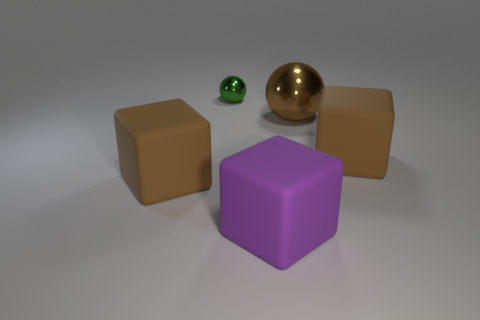Do the tiny object and the matte object to the right of the brown metallic ball have the same color?
Your answer should be very brief. No. Are there any brown spheres that have the same size as the brown shiny thing?
Offer a terse response. No. There is a brown block that is right of the green shiny sphere; what is it made of?
Ensure brevity in your answer.  Rubber. Is the number of large metallic objects left of the tiny metal sphere the same as the number of big cubes that are on the right side of the big brown sphere?
Your response must be concise. No. Is the size of the ball that is to the right of the tiny shiny thing the same as the cube to the left of the green shiny object?
Your answer should be compact. Yes. What number of other shiny objects are the same color as the large shiny object?
Keep it short and to the point. 0. Is the number of tiny balls that are in front of the small green shiny ball greater than the number of big purple rubber objects?
Give a very brief answer. No. Does the purple matte object have the same shape as the small green metallic thing?
Keep it short and to the point. No. How many other things have the same material as the big purple thing?
Offer a very short reply. 2. There is another metal object that is the same shape as the tiny metal object; what size is it?
Your response must be concise. Large. 